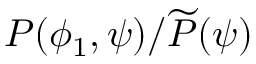Convert formula to latex. <formula><loc_0><loc_0><loc_500><loc_500>P ( \phi _ { 1 } , \psi ) / \widetilde { P } ( \psi )</formula> 